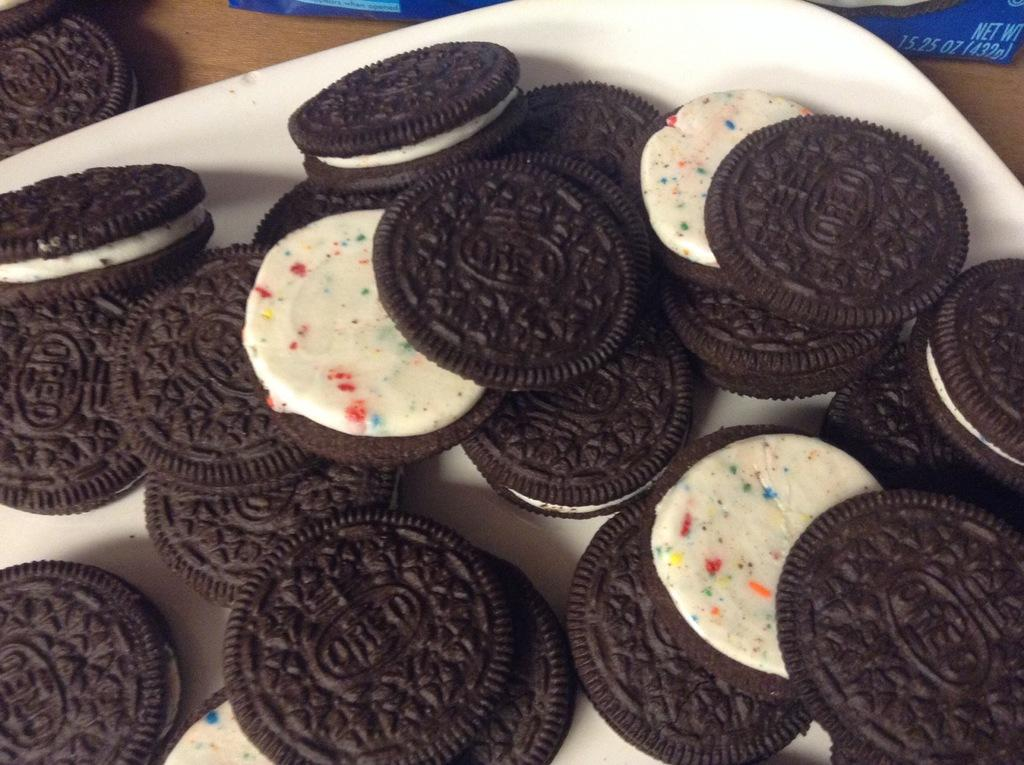What type of biscuits are in the image? There are Oreo biscuits in the image. What is the color of the biscuits? The biscuits are brown in color. What is present between the biscuits? There is cream between the biscuits. Where are the biscuits placed? The biscuits are on a plate. What type of instrument is being played in the image? There is no instrument present in the image; it features Oreo biscuits on a plate. What type of society is depicted in the image? The image does not depict any society; it features Oreo biscuits on a plate. 